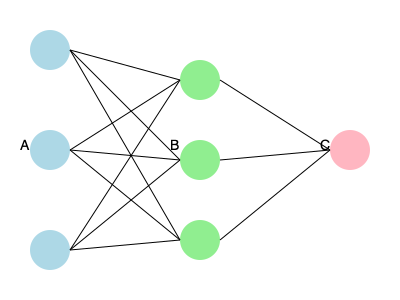In the given neural network architecture diagram, identify the components labeled A, B, and C. To identify the components of this basic neural network architecture, let's analyze the diagram step-by-step:

1. Component A:
   - Located on the left side of the diagram
   - Consists of three nodes (circles)
   - First layer in the network
   This is the input layer, where data is fed into the neural network.

2. Component B:
   - Located in the middle of the diagram
   - Also consists of three nodes
   - Receives connections from all nodes in the input layer
   This is the hidden layer, which processes the input data and learns complex features.

3. Component C:
   - Located on the right side of the diagram
   - Consists of a single node
   - Receives connections from all nodes in the hidden layer
   This is the output layer, which produces the final result or prediction of the neural network.

The connections between the layers represent the weights and biases that the neural network learns during training to make accurate predictions.
Answer: A: Input layer, B: Hidden layer, C: Output layer 